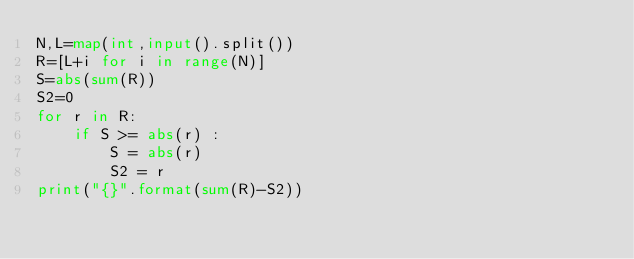Convert code to text. <code><loc_0><loc_0><loc_500><loc_500><_Python_>N,L=map(int,input().split())
R=[L+i for i in range(N)]
S=abs(sum(R))
S2=0
for r in R:
    if S >= abs(r) :
        S = abs(r)
        S2 = r
print("{}".format(sum(R)-S2))
</code> 